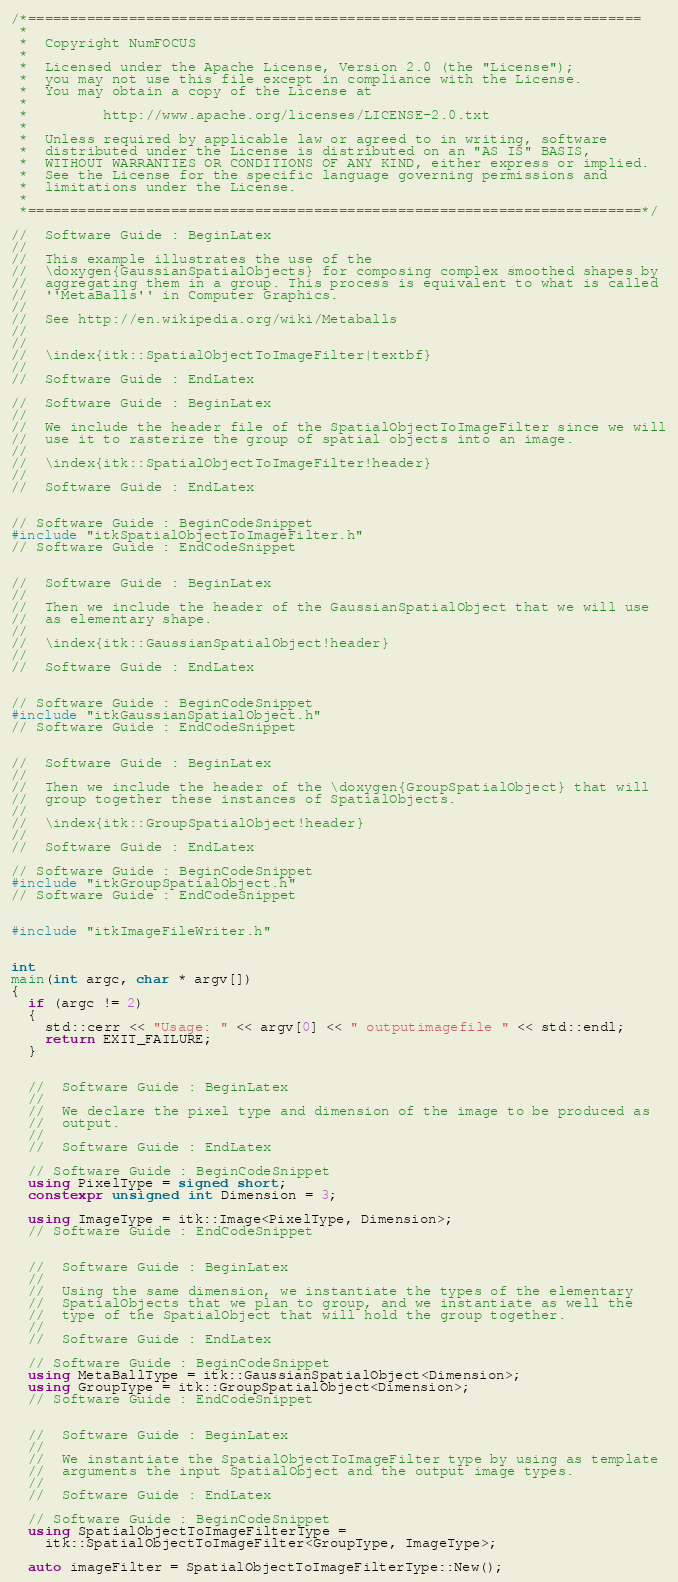<code> <loc_0><loc_0><loc_500><loc_500><_C++_>/*=========================================================================
 *
 *  Copyright NumFOCUS
 *
 *  Licensed under the Apache License, Version 2.0 (the "License");
 *  you may not use this file except in compliance with the License.
 *  You may obtain a copy of the License at
 *
 *         http://www.apache.org/licenses/LICENSE-2.0.txt
 *
 *  Unless required by applicable law or agreed to in writing, software
 *  distributed under the License is distributed on an "AS IS" BASIS,
 *  WITHOUT WARRANTIES OR CONDITIONS OF ANY KIND, either express or implied.
 *  See the License for the specific language governing permissions and
 *  limitations under the License.
 *
 *=========================================================================*/

//  Software Guide : BeginLatex
//
//  This example illustrates the use of the
//  \doxygen{GaussianSpatialObjects} for composing complex smoothed shapes by
//  aggregating them in a group. This process is equivalent to what is called
//  ''MetaBalls'' in Computer Graphics.
//
//  See http://en.wikipedia.org/wiki/Metaballs
//
//
//  \index{itk::SpatialObjectToImageFilter|textbf}
//
//  Software Guide : EndLatex

//  Software Guide : BeginLatex
//
//  We include the header file of the SpatialObjectToImageFilter since we will
//  use it to rasterize the group of spatial objects into an image.
//
//  \index{itk::SpatialObjectToImageFilter!header}
//
//  Software Guide : EndLatex


// Software Guide : BeginCodeSnippet
#include "itkSpatialObjectToImageFilter.h"
// Software Guide : EndCodeSnippet


//  Software Guide : BeginLatex
//
//  Then we include the header of the GaussianSpatialObject that we will use
//  as elementary shape.
//
//  \index{itk::GaussianSpatialObject!header}
//
//  Software Guide : EndLatex


// Software Guide : BeginCodeSnippet
#include "itkGaussianSpatialObject.h"
// Software Guide : EndCodeSnippet


//  Software Guide : BeginLatex
//
//  Then we include the header of the \doxygen{GroupSpatialObject} that will
//  group together these instances of SpatialObjects.
//
//  \index{itk::GroupSpatialObject!header}
//
//  Software Guide : EndLatex

// Software Guide : BeginCodeSnippet
#include "itkGroupSpatialObject.h"
// Software Guide : EndCodeSnippet


#include "itkImageFileWriter.h"


int
main(int argc, char * argv[])
{
  if (argc != 2)
  {
    std::cerr << "Usage: " << argv[0] << " outputimagefile " << std::endl;
    return EXIT_FAILURE;
  }


  //  Software Guide : BeginLatex
  //
  //  We declare the pixel type and dimension of the image to be produced as
  //  output.
  //
  //  Software Guide : EndLatex

  // Software Guide : BeginCodeSnippet
  using PixelType = signed short;
  constexpr unsigned int Dimension = 3;

  using ImageType = itk::Image<PixelType, Dimension>;
  // Software Guide : EndCodeSnippet


  //  Software Guide : BeginLatex
  //
  //  Using the same dimension, we instantiate the types of the elementary
  //  SpatialObjects that we plan to group, and we instantiate as well the
  //  type of the SpatialObject that will hold the group together.
  //
  //  Software Guide : EndLatex

  // Software Guide : BeginCodeSnippet
  using MetaBallType = itk::GaussianSpatialObject<Dimension>;
  using GroupType = itk::GroupSpatialObject<Dimension>;
  // Software Guide : EndCodeSnippet


  //  Software Guide : BeginLatex
  //
  //  We instantiate the SpatialObjectToImageFilter type by using as template
  //  arguments the input SpatialObject and the output image types.
  //
  //  Software Guide : EndLatex

  // Software Guide : BeginCodeSnippet
  using SpatialObjectToImageFilterType =
    itk::SpatialObjectToImageFilter<GroupType, ImageType>;

  auto imageFilter = SpatialObjectToImageFilterType::New();</code> 